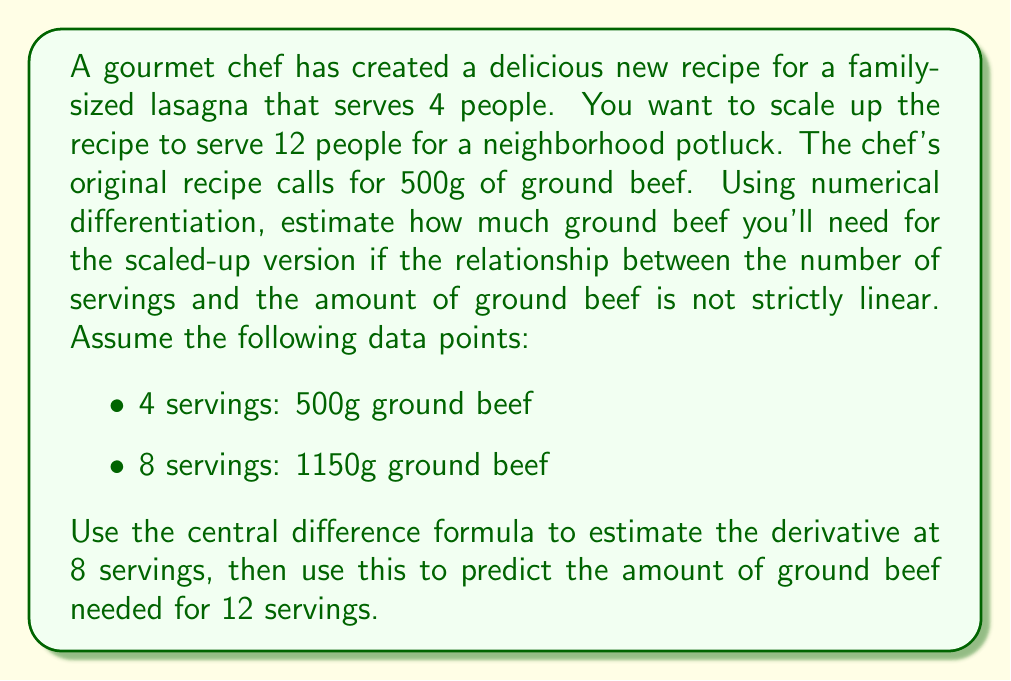What is the answer to this math problem? Let's approach this step-by-step:

1) First, we'll use the central difference formula to estimate the derivative at 8 servings. The central difference formula is:

   $$f'(x) \approx \frac{f(x+h) - f(x-h)}{2h}$$

   Where $h$ is the step size.

2) In our case:
   $x = 8$ servings
   $h = 4$ servings
   $f(x-h) = f(4) = 500$g
   $f(x+h) = f(12)$ is unknown
   $f(x) = f(8) = 1150$g

3) We can rearrange the formula to solve for $f(12)$:

   $$f'(8) \approx \frac{f(12) - 500}{2(4)}$$

4) To estimate $f'(8)$, we can use the average rate of change between 4 and 8 servings:

   $$f'(8) \approx \frac{1150 - 500}{8 - 4} = \frac{650}{4} = 162.5$$

5) Now we can set up the equation:

   $$162.5 \approx \frac{f(12) - 500}{8}$$

6) Solve for $f(12)$:

   $$8(162.5) \approx f(12) - 500$$
   $$1300 + 500 \approx f(12)$$
   $$f(12) \approx 1800$$

Therefore, the estimated amount of ground beef needed for 12 servings is approximately 1800g.
Answer: Approximately 1800g of ground beef 